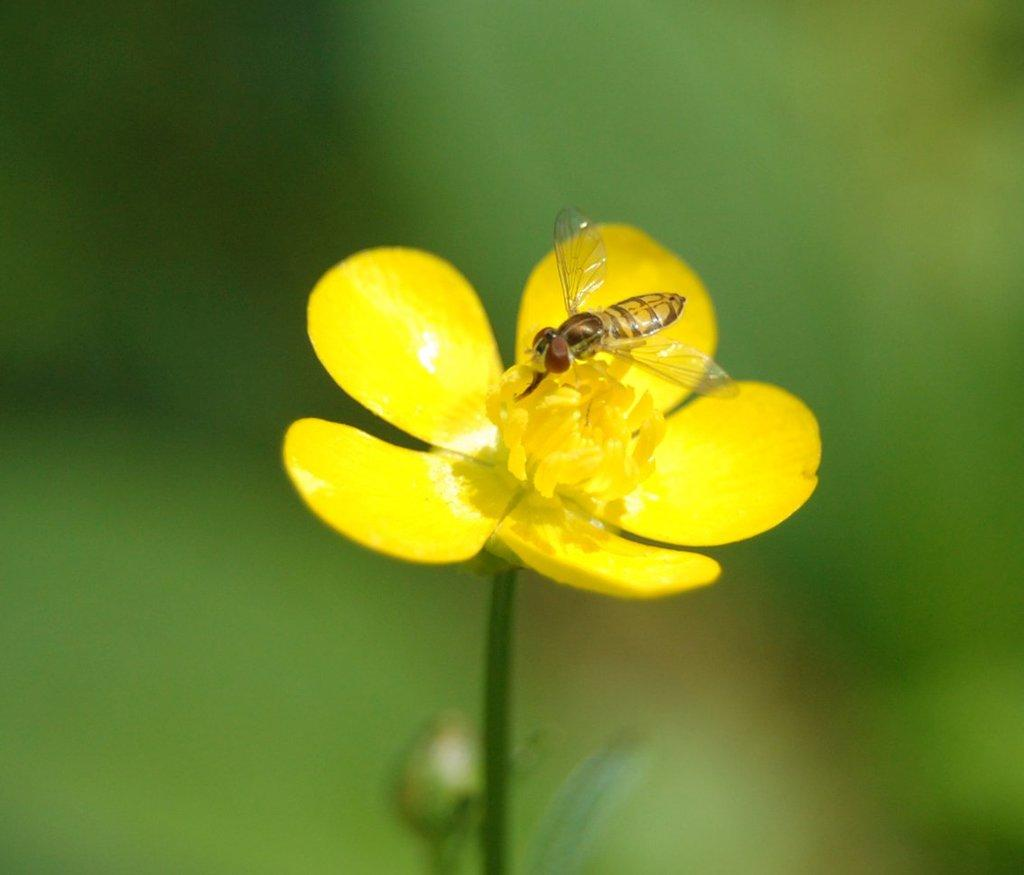What type of flower is in the picture? There is a yellow flower in the picture. Is there anything on the flower? Yes, there is an insect on the flower. Can you describe the background of the image? The backdrop of the image is blurred. What type of snail can be seen crawling on the harmony in the image? There is no snail or harmony present in the image; it features a yellow flower with an insect on it. 